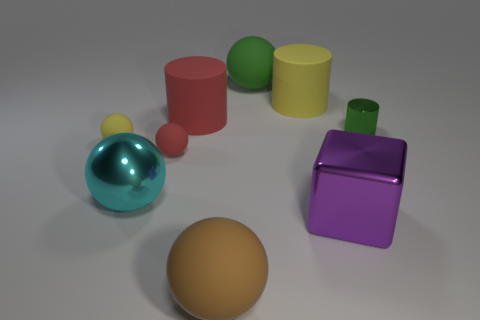Which object looks the heaviest and why? The purple cube appears to be the heaviest object due to its size and the solid look of its geometry, making it look denser and sturdier than the other objects in the image. 